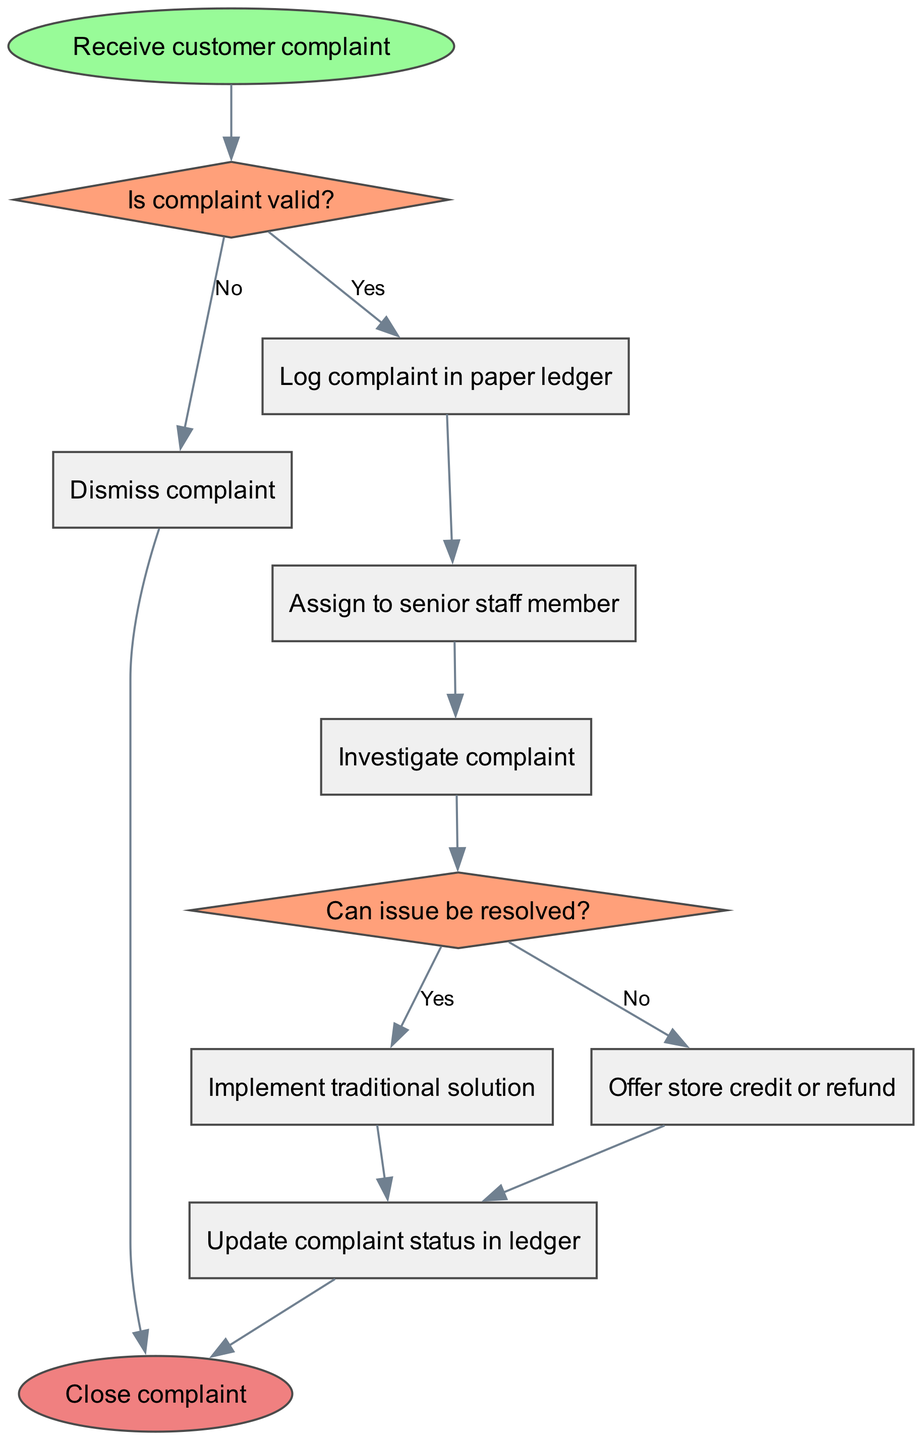What is the start node of the process? The start node is specified in the diagram data as "Receive customer complaint."
Answer: Receive customer complaint How many process nodes are there? The diagram includes processes from process1 to process7, making a total of seven process nodes.
Answer: 7 What happens if the complaint is not valid? According to the diagram, if the complaint is not valid, the flow moves to process1, which is "Dismiss complaint."
Answer: Dismiss complaint What action follows after logging the complaint in the paper ledger? The diagram indicates that after logging the complaint in the paper ledger, the next action is to "Assign to senior staff member."
Answer: Assign to senior staff member What options are available if the issue can be resolved? If the issue can be resolved, the flow diagram shows the option to either "Implement traditional solution" or "Offer store credit or refund."
Answer: Implement traditional solution or Offer store credit or refund What is the final action in the handling process? The final part of the process is indicated in the diagram as "Close complaint," denoting the end of the handling process.
Answer: Close complaint What decision point occurs after investigating the complaint? After investigating the complaint, the process includes a decision point labeled "Can issue be resolved?" which determines the next course of action.
Answer: Can issue be resolved? What happens to the complaint after a traditional solution is implemented? After the implementation of a traditional solution, the next step in the flow is to "Update complaint status in ledger."
Answer: Update complaint status in ledger 